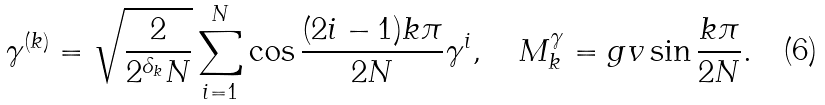Convert formula to latex. <formula><loc_0><loc_0><loc_500><loc_500>\gamma ^ { ( k ) } = \sqrt { \frac { 2 } { 2 ^ { \delta _ { k } } N } } \sum _ { i = 1 } ^ { N } \cos \frac { ( 2 i - 1 ) k \pi } { 2 N } \gamma ^ { i } , \quad M ^ { \gamma } _ { k } = g v \sin \frac { k \pi } { 2 N } .</formula> 